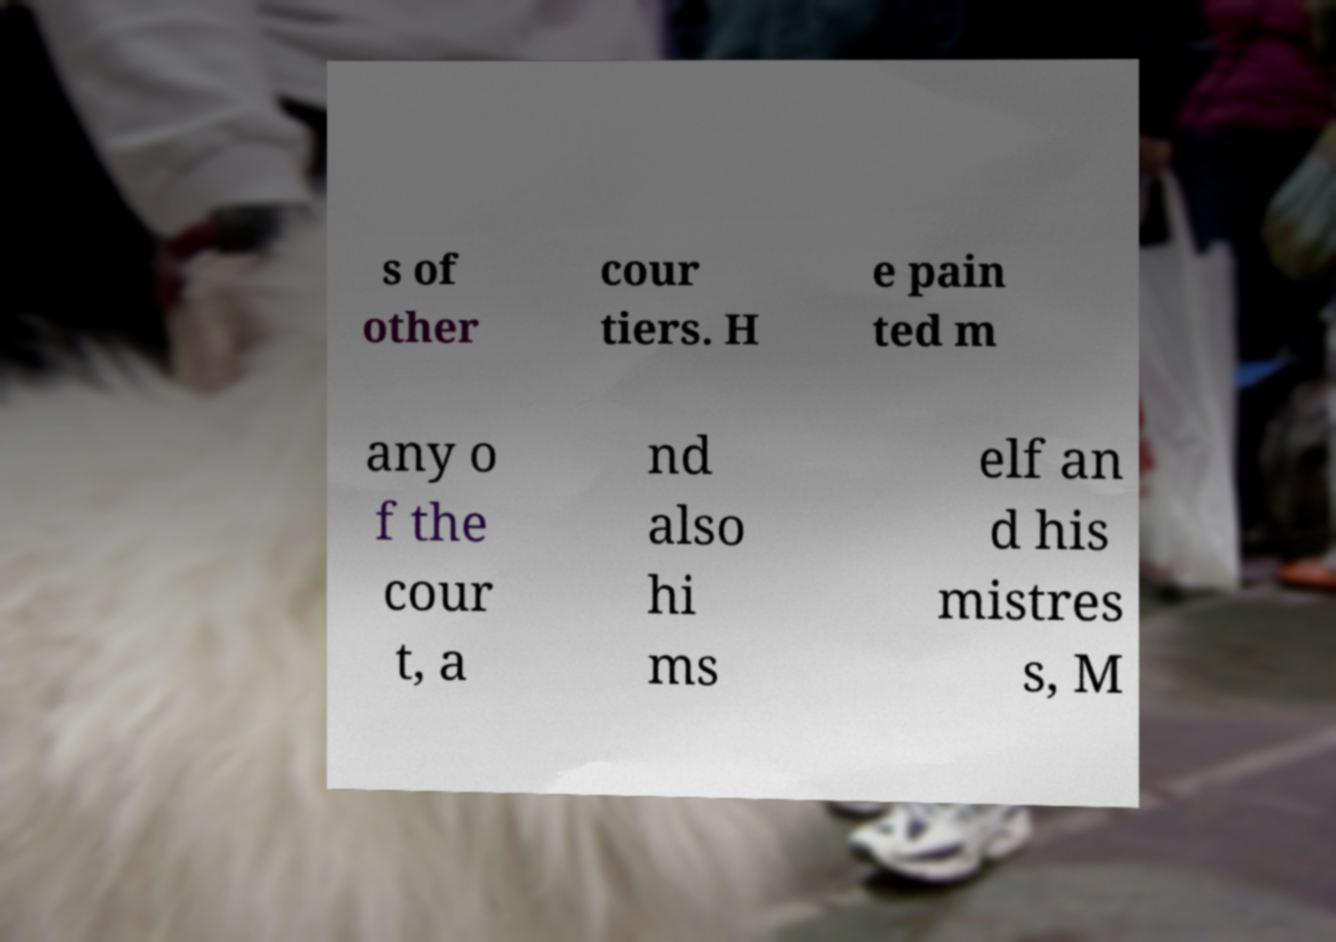Can you accurately transcribe the text from the provided image for me? s of other cour tiers. H e pain ted m any o f the cour t, a nd also hi ms elf an d his mistres s, M 